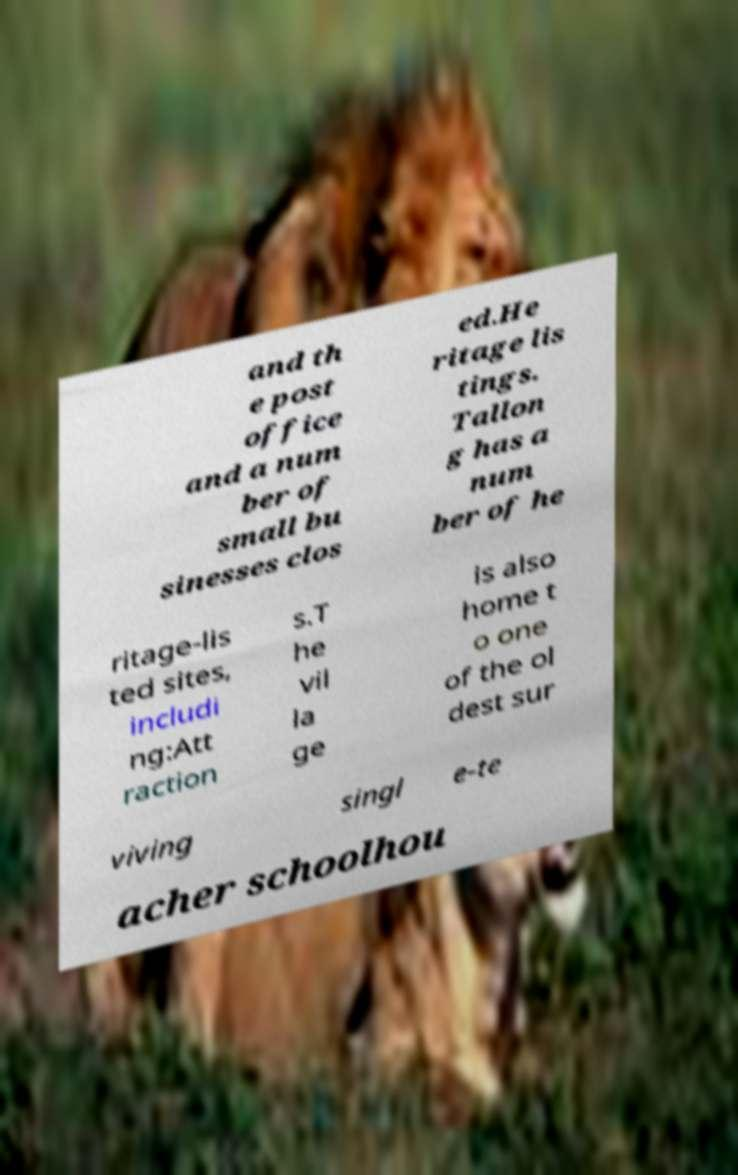I need the written content from this picture converted into text. Can you do that? and th e post office and a num ber of small bu sinesses clos ed.He ritage lis tings. Tallon g has a num ber of he ritage-lis ted sites, includi ng:Att raction s.T he vil la ge is also home t o one of the ol dest sur viving singl e-te acher schoolhou 